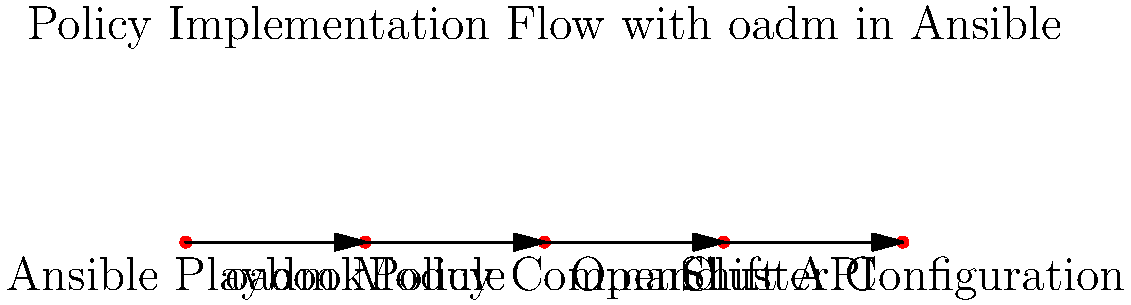In the diagram illustrating the flow of policy implementation using oadm in Ansible, what is the component directly following the "oadm Module" in the process? To answer this question, let's analyze the diagram step-by-step:

1. The flow starts with "Ansible Playbook", which is the first component in the diagram.
2. The second component is the "oadm Module", which is called by the Ansible Playbook.
3. Following the "oadm Module", we can see the next component in the flow is the "Policy Command".
4. After the "Policy Command", the flow continues to the "OpenShift API".
5. Finally, the process ends with "Cluster Configuration".

The question specifically asks about the component directly following the "oadm Module". By tracing the arrow from the "oadm Module", we can see that it points directly to the "Policy Command".

Therefore, the component directly following the "oadm Module" in the policy implementation flow is the "Policy Command".
Answer: Policy Command 